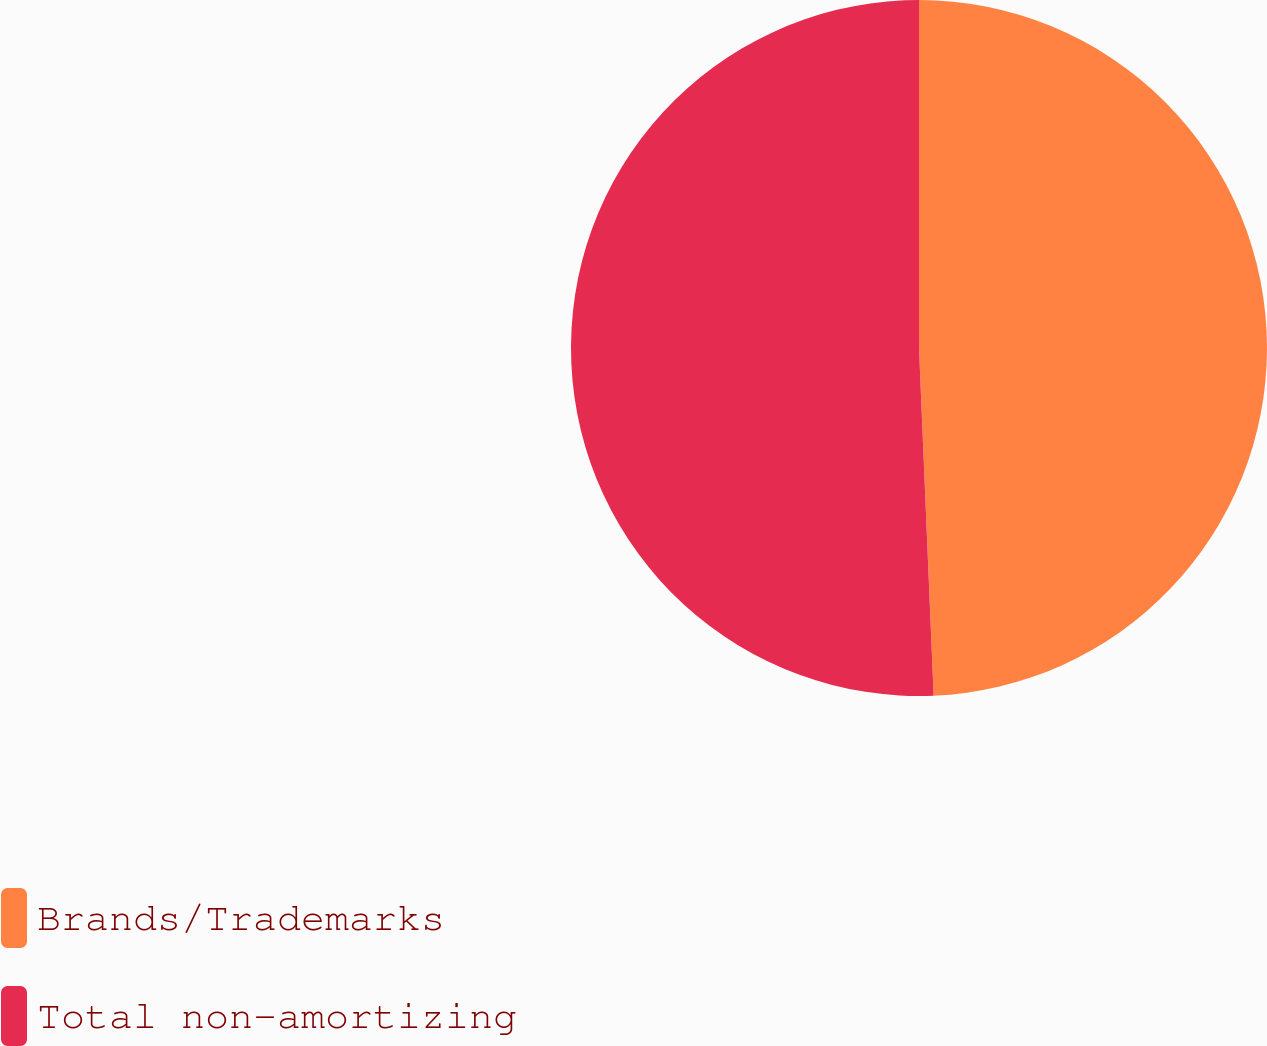Convert chart to OTSL. <chart><loc_0><loc_0><loc_500><loc_500><pie_chart><fcel>Brands/Trademarks<fcel>Total non-amortizing<nl><fcel>49.33%<fcel>50.67%<nl></chart> 